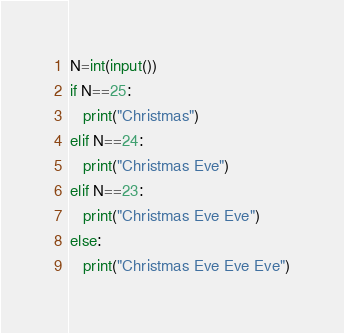<code> <loc_0><loc_0><loc_500><loc_500><_Python_>N=int(input())
if N==25:
   print("Christmas")
elif N==24:
   print("Christmas Eve")
elif N==23:
   print("Christmas Eve Eve")
else:
   print("Christmas Eve Eve Eve")</code> 